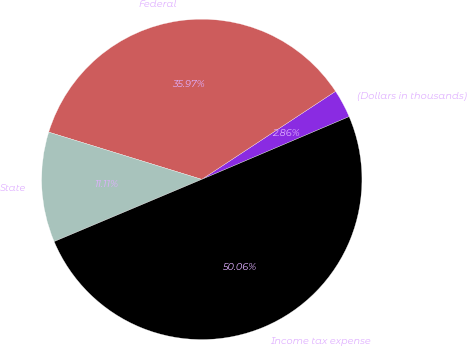<chart> <loc_0><loc_0><loc_500><loc_500><pie_chart><fcel>(Dollars in thousands)<fcel>Federal<fcel>State<fcel>Income tax expense<nl><fcel>2.86%<fcel>35.97%<fcel>11.11%<fcel>50.06%<nl></chart> 